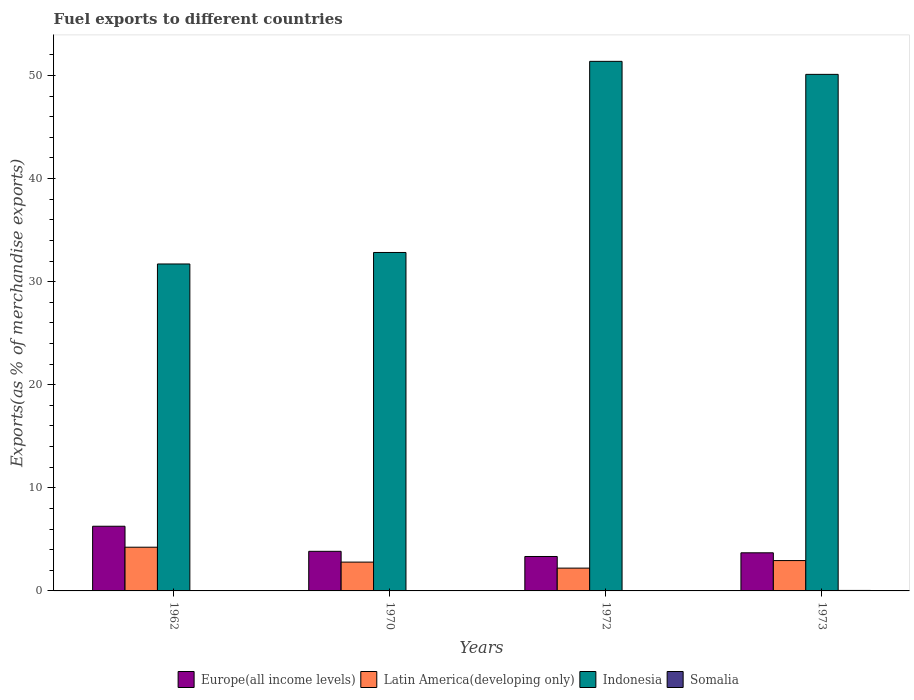How many groups of bars are there?
Your answer should be compact. 4. Are the number of bars per tick equal to the number of legend labels?
Your response must be concise. Yes. Are the number of bars on each tick of the X-axis equal?
Provide a succinct answer. Yes. How many bars are there on the 4th tick from the left?
Offer a terse response. 4. How many bars are there on the 1st tick from the right?
Make the answer very short. 4. What is the label of the 1st group of bars from the left?
Make the answer very short. 1962. In how many cases, is the number of bars for a given year not equal to the number of legend labels?
Offer a very short reply. 0. What is the percentage of exports to different countries in Indonesia in 1972?
Ensure brevity in your answer.  51.36. Across all years, what is the maximum percentage of exports to different countries in Somalia?
Ensure brevity in your answer.  0.05. Across all years, what is the minimum percentage of exports to different countries in Latin America(developing only)?
Your response must be concise. 2.21. What is the total percentage of exports to different countries in Latin America(developing only) in the graph?
Offer a very short reply. 12.19. What is the difference between the percentage of exports to different countries in Europe(all income levels) in 1962 and that in 1973?
Provide a short and direct response. 2.58. What is the difference between the percentage of exports to different countries in Indonesia in 1962 and the percentage of exports to different countries in Latin America(developing only) in 1970?
Offer a very short reply. 28.92. What is the average percentage of exports to different countries in Latin America(developing only) per year?
Ensure brevity in your answer.  3.05. In the year 1972, what is the difference between the percentage of exports to different countries in Indonesia and percentage of exports to different countries in Latin America(developing only)?
Your response must be concise. 49.15. In how many years, is the percentage of exports to different countries in Indonesia greater than 38 %?
Offer a terse response. 2. What is the ratio of the percentage of exports to different countries in Somalia in 1962 to that in 1972?
Your response must be concise. 0.26. Is the difference between the percentage of exports to different countries in Indonesia in 1962 and 1972 greater than the difference between the percentage of exports to different countries in Latin America(developing only) in 1962 and 1972?
Your answer should be very brief. No. What is the difference between the highest and the second highest percentage of exports to different countries in Indonesia?
Ensure brevity in your answer.  1.26. What is the difference between the highest and the lowest percentage of exports to different countries in Latin America(developing only)?
Offer a terse response. 2.03. In how many years, is the percentage of exports to different countries in Somalia greater than the average percentage of exports to different countries in Somalia taken over all years?
Make the answer very short. 1. Is the sum of the percentage of exports to different countries in Indonesia in 1962 and 1973 greater than the maximum percentage of exports to different countries in Latin America(developing only) across all years?
Provide a short and direct response. Yes. Is it the case that in every year, the sum of the percentage of exports to different countries in Somalia and percentage of exports to different countries in Latin America(developing only) is greater than the sum of percentage of exports to different countries in Indonesia and percentage of exports to different countries in Europe(all income levels)?
Provide a short and direct response. No. What does the 2nd bar from the left in 1972 represents?
Your response must be concise. Latin America(developing only). Are all the bars in the graph horizontal?
Your answer should be compact. No. Are the values on the major ticks of Y-axis written in scientific E-notation?
Offer a very short reply. No. Does the graph contain any zero values?
Give a very brief answer. No. Where does the legend appear in the graph?
Your response must be concise. Bottom center. How many legend labels are there?
Offer a very short reply. 4. How are the legend labels stacked?
Make the answer very short. Horizontal. What is the title of the graph?
Ensure brevity in your answer.  Fuel exports to different countries. What is the label or title of the Y-axis?
Give a very brief answer. Exports(as % of merchandise exports). What is the Exports(as % of merchandise exports) of Europe(all income levels) in 1962?
Offer a very short reply. 6.27. What is the Exports(as % of merchandise exports) of Latin America(developing only) in 1962?
Make the answer very short. 4.24. What is the Exports(as % of merchandise exports) of Indonesia in 1962?
Ensure brevity in your answer.  31.71. What is the Exports(as % of merchandise exports) of Somalia in 1962?
Provide a short and direct response. 0. What is the Exports(as % of merchandise exports) of Europe(all income levels) in 1970?
Keep it short and to the point. 3.84. What is the Exports(as % of merchandise exports) in Latin America(developing only) in 1970?
Your response must be concise. 2.8. What is the Exports(as % of merchandise exports) in Indonesia in 1970?
Give a very brief answer. 32.83. What is the Exports(as % of merchandise exports) of Somalia in 1970?
Your answer should be compact. 0. What is the Exports(as % of merchandise exports) in Europe(all income levels) in 1972?
Your answer should be compact. 3.34. What is the Exports(as % of merchandise exports) of Latin America(developing only) in 1972?
Make the answer very short. 2.21. What is the Exports(as % of merchandise exports) in Indonesia in 1972?
Provide a short and direct response. 51.36. What is the Exports(as % of merchandise exports) of Somalia in 1972?
Offer a terse response. 0.01. What is the Exports(as % of merchandise exports) of Europe(all income levels) in 1973?
Provide a short and direct response. 3.7. What is the Exports(as % of merchandise exports) of Latin America(developing only) in 1973?
Your answer should be compact. 2.94. What is the Exports(as % of merchandise exports) in Indonesia in 1973?
Your answer should be very brief. 50.1. What is the Exports(as % of merchandise exports) in Somalia in 1973?
Your answer should be compact. 0.05. Across all years, what is the maximum Exports(as % of merchandise exports) of Europe(all income levels)?
Make the answer very short. 6.27. Across all years, what is the maximum Exports(as % of merchandise exports) in Latin America(developing only)?
Keep it short and to the point. 4.24. Across all years, what is the maximum Exports(as % of merchandise exports) in Indonesia?
Ensure brevity in your answer.  51.36. Across all years, what is the maximum Exports(as % of merchandise exports) of Somalia?
Give a very brief answer. 0.05. Across all years, what is the minimum Exports(as % of merchandise exports) of Europe(all income levels)?
Give a very brief answer. 3.34. Across all years, what is the minimum Exports(as % of merchandise exports) in Latin America(developing only)?
Keep it short and to the point. 2.21. Across all years, what is the minimum Exports(as % of merchandise exports) of Indonesia?
Your answer should be compact. 31.71. Across all years, what is the minimum Exports(as % of merchandise exports) in Somalia?
Ensure brevity in your answer.  0. What is the total Exports(as % of merchandise exports) in Europe(all income levels) in the graph?
Provide a short and direct response. 17.15. What is the total Exports(as % of merchandise exports) in Latin America(developing only) in the graph?
Your response must be concise. 12.19. What is the total Exports(as % of merchandise exports) of Indonesia in the graph?
Keep it short and to the point. 166. What is the total Exports(as % of merchandise exports) of Somalia in the graph?
Ensure brevity in your answer.  0.06. What is the difference between the Exports(as % of merchandise exports) of Europe(all income levels) in 1962 and that in 1970?
Ensure brevity in your answer.  2.43. What is the difference between the Exports(as % of merchandise exports) of Latin America(developing only) in 1962 and that in 1970?
Offer a terse response. 1.44. What is the difference between the Exports(as % of merchandise exports) in Indonesia in 1962 and that in 1970?
Keep it short and to the point. -1.11. What is the difference between the Exports(as % of merchandise exports) in Somalia in 1962 and that in 1970?
Your response must be concise. 0. What is the difference between the Exports(as % of merchandise exports) of Europe(all income levels) in 1962 and that in 1972?
Make the answer very short. 2.93. What is the difference between the Exports(as % of merchandise exports) of Latin America(developing only) in 1962 and that in 1972?
Give a very brief answer. 2.03. What is the difference between the Exports(as % of merchandise exports) in Indonesia in 1962 and that in 1972?
Offer a very short reply. -19.65. What is the difference between the Exports(as % of merchandise exports) of Somalia in 1962 and that in 1972?
Keep it short and to the point. -0.01. What is the difference between the Exports(as % of merchandise exports) of Europe(all income levels) in 1962 and that in 1973?
Provide a short and direct response. 2.58. What is the difference between the Exports(as % of merchandise exports) of Latin America(developing only) in 1962 and that in 1973?
Your answer should be compact. 1.3. What is the difference between the Exports(as % of merchandise exports) in Indonesia in 1962 and that in 1973?
Offer a terse response. -18.39. What is the difference between the Exports(as % of merchandise exports) of Somalia in 1962 and that in 1973?
Provide a short and direct response. -0.04. What is the difference between the Exports(as % of merchandise exports) in Europe(all income levels) in 1970 and that in 1972?
Provide a short and direct response. 0.5. What is the difference between the Exports(as % of merchandise exports) in Latin America(developing only) in 1970 and that in 1972?
Your answer should be compact. 0.58. What is the difference between the Exports(as % of merchandise exports) in Indonesia in 1970 and that in 1972?
Give a very brief answer. -18.54. What is the difference between the Exports(as % of merchandise exports) in Somalia in 1970 and that in 1972?
Ensure brevity in your answer.  -0.01. What is the difference between the Exports(as % of merchandise exports) of Europe(all income levels) in 1970 and that in 1973?
Give a very brief answer. 0.14. What is the difference between the Exports(as % of merchandise exports) of Latin America(developing only) in 1970 and that in 1973?
Offer a very short reply. -0.15. What is the difference between the Exports(as % of merchandise exports) of Indonesia in 1970 and that in 1973?
Your answer should be very brief. -17.28. What is the difference between the Exports(as % of merchandise exports) in Somalia in 1970 and that in 1973?
Give a very brief answer. -0.05. What is the difference between the Exports(as % of merchandise exports) in Europe(all income levels) in 1972 and that in 1973?
Your response must be concise. -0.36. What is the difference between the Exports(as % of merchandise exports) in Latin America(developing only) in 1972 and that in 1973?
Keep it short and to the point. -0.73. What is the difference between the Exports(as % of merchandise exports) of Indonesia in 1972 and that in 1973?
Offer a very short reply. 1.26. What is the difference between the Exports(as % of merchandise exports) in Somalia in 1972 and that in 1973?
Your answer should be very brief. -0.04. What is the difference between the Exports(as % of merchandise exports) in Europe(all income levels) in 1962 and the Exports(as % of merchandise exports) in Latin America(developing only) in 1970?
Offer a terse response. 3.48. What is the difference between the Exports(as % of merchandise exports) of Europe(all income levels) in 1962 and the Exports(as % of merchandise exports) of Indonesia in 1970?
Offer a very short reply. -26.55. What is the difference between the Exports(as % of merchandise exports) of Europe(all income levels) in 1962 and the Exports(as % of merchandise exports) of Somalia in 1970?
Give a very brief answer. 6.27. What is the difference between the Exports(as % of merchandise exports) of Latin America(developing only) in 1962 and the Exports(as % of merchandise exports) of Indonesia in 1970?
Provide a short and direct response. -28.59. What is the difference between the Exports(as % of merchandise exports) in Latin America(developing only) in 1962 and the Exports(as % of merchandise exports) in Somalia in 1970?
Offer a terse response. 4.24. What is the difference between the Exports(as % of merchandise exports) in Indonesia in 1962 and the Exports(as % of merchandise exports) in Somalia in 1970?
Offer a very short reply. 31.71. What is the difference between the Exports(as % of merchandise exports) in Europe(all income levels) in 1962 and the Exports(as % of merchandise exports) in Latin America(developing only) in 1972?
Keep it short and to the point. 4.06. What is the difference between the Exports(as % of merchandise exports) in Europe(all income levels) in 1962 and the Exports(as % of merchandise exports) in Indonesia in 1972?
Your response must be concise. -45.09. What is the difference between the Exports(as % of merchandise exports) in Europe(all income levels) in 1962 and the Exports(as % of merchandise exports) in Somalia in 1972?
Provide a short and direct response. 6.26. What is the difference between the Exports(as % of merchandise exports) of Latin America(developing only) in 1962 and the Exports(as % of merchandise exports) of Indonesia in 1972?
Keep it short and to the point. -47.13. What is the difference between the Exports(as % of merchandise exports) in Latin America(developing only) in 1962 and the Exports(as % of merchandise exports) in Somalia in 1972?
Provide a short and direct response. 4.23. What is the difference between the Exports(as % of merchandise exports) in Indonesia in 1962 and the Exports(as % of merchandise exports) in Somalia in 1972?
Make the answer very short. 31.7. What is the difference between the Exports(as % of merchandise exports) of Europe(all income levels) in 1962 and the Exports(as % of merchandise exports) of Latin America(developing only) in 1973?
Provide a succinct answer. 3.33. What is the difference between the Exports(as % of merchandise exports) of Europe(all income levels) in 1962 and the Exports(as % of merchandise exports) of Indonesia in 1973?
Keep it short and to the point. -43.83. What is the difference between the Exports(as % of merchandise exports) of Europe(all income levels) in 1962 and the Exports(as % of merchandise exports) of Somalia in 1973?
Make the answer very short. 6.23. What is the difference between the Exports(as % of merchandise exports) of Latin America(developing only) in 1962 and the Exports(as % of merchandise exports) of Indonesia in 1973?
Provide a succinct answer. -45.86. What is the difference between the Exports(as % of merchandise exports) of Latin America(developing only) in 1962 and the Exports(as % of merchandise exports) of Somalia in 1973?
Your answer should be compact. 4.19. What is the difference between the Exports(as % of merchandise exports) of Indonesia in 1962 and the Exports(as % of merchandise exports) of Somalia in 1973?
Your answer should be very brief. 31.66. What is the difference between the Exports(as % of merchandise exports) in Europe(all income levels) in 1970 and the Exports(as % of merchandise exports) in Latin America(developing only) in 1972?
Give a very brief answer. 1.63. What is the difference between the Exports(as % of merchandise exports) in Europe(all income levels) in 1970 and the Exports(as % of merchandise exports) in Indonesia in 1972?
Offer a terse response. -47.52. What is the difference between the Exports(as % of merchandise exports) of Europe(all income levels) in 1970 and the Exports(as % of merchandise exports) of Somalia in 1972?
Your answer should be very brief. 3.83. What is the difference between the Exports(as % of merchandise exports) in Latin America(developing only) in 1970 and the Exports(as % of merchandise exports) in Indonesia in 1972?
Offer a terse response. -48.57. What is the difference between the Exports(as % of merchandise exports) of Latin America(developing only) in 1970 and the Exports(as % of merchandise exports) of Somalia in 1972?
Offer a very short reply. 2.78. What is the difference between the Exports(as % of merchandise exports) of Indonesia in 1970 and the Exports(as % of merchandise exports) of Somalia in 1972?
Your answer should be very brief. 32.81. What is the difference between the Exports(as % of merchandise exports) of Europe(all income levels) in 1970 and the Exports(as % of merchandise exports) of Latin America(developing only) in 1973?
Your response must be concise. 0.9. What is the difference between the Exports(as % of merchandise exports) of Europe(all income levels) in 1970 and the Exports(as % of merchandise exports) of Indonesia in 1973?
Provide a short and direct response. -46.26. What is the difference between the Exports(as % of merchandise exports) of Europe(all income levels) in 1970 and the Exports(as % of merchandise exports) of Somalia in 1973?
Make the answer very short. 3.79. What is the difference between the Exports(as % of merchandise exports) in Latin America(developing only) in 1970 and the Exports(as % of merchandise exports) in Indonesia in 1973?
Your answer should be very brief. -47.31. What is the difference between the Exports(as % of merchandise exports) in Latin America(developing only) in 1970 and the Exports(as % of merchandise exports) in Somalia in 1973?
Ensure brevity in your answer.  2.75. What is the difference between the Exports(as % of merchandise exports) of Indonesia in 1970 and the Exports(as % of merchandise exports) of Somalia in 1973?
Make the answer very short. 32.78. What is the difference between the Exports(as % of merchandise exports) in Europe(all income levels) in 1972 and the Exports(as % of merchandise exports) in Latin America(developing only) in 1973?
Offer a very short reply. 0.4. What is the difference between the Exports(as % of merchandise exports) in Europe(all income levels) in 1972 and the Exports(as % of merchandise exports) in Indonesia in 1973?
Ensure brevity in your answer.  -46.76. What is the difference between the Exports(as % of merchandise exports) of Europe(all income levels) in 1972 and the Exports(as % of merchandise exports) of Somalia in 1973?
Ensure brevity in your answer.  3.29. What is the difference between the Exports(as % of merchandise exports) in Latin America(developing only) in 1972 and the Exports(as % of merchandise exports) in Indonesia in 1973?
Give a very brief answer. -47.89. What is the difference between the Exports(as % of merchandise exports) of Latin America(developing only) in 1972 and the Exports(as % of merchandise exports) of Somalia in 1973?
Your answer should be compact. 2.17. What is the difference between the Exports(as % of merchandise exports) of Indonesia in 1972 and the Exports(as % of merchandise exports) of Somalia in 1973?
Keep it short and to the point. 51.32. What is the average Exports(as % of merchandise exports) in Europe(all income levels) per year?
Your answer should be compact. 4.29. What is the average Exports(as % of merchandise exports) of Latin America(developing only) per year?
Your response must be concise. 3.05. What is the average Exports(as % of merchandise exports) of Indonesia per year?
Ensure brevity in your answer.  41.5. What is the average Exports(as % of merchandise exports) in Somalia per year?
Keep it short and to the point. 0.02. In the year 1962, what is the difference between the Exports(as % of merchandise exports) in Europe(all income levels) and Exports(as % of merchandise exports) in Latin America(developing only)?
Keep it short and to the point. 2.03. In the year 1962, what is the difference between the Exports(as % of merchandise exports) in Europe(all income levels) and Exports(as % of merchandise exports) in Indonesia?
Make the answer very short. -25.44. In the year 1962, what is the difference between the Exports(as % of merchandise exports) in Europe(all income levels) and Exports(as % of merchandise exports) in Somalia?
Provide a short and direct response. 6.27. In the year 1962, what is the difference between the Exports(as % of merchandise exports) of Latin America(developing only) and Exports(as % of merchandise exports) of Indonesia?
Provide a succinct answer. -27.47. In the year 1962, what is the difference between the Exports(as % of merchandise exports) in Latin America(developing only) and Exports(as % of merchandise exports) in Somalia?
Offer a terse response. 4.24. In the year 1962, what is the difference between the Exports(as % of merchandise exports) in Indonesia and Exports(as % of merchandise exports) in Somalia?
Offer a terse response. 31.71. In the year 1970, what is the difference between the Exports(as % of merchandise exports) in Europe(all income levels) and Exports(as % of merchandise exports) in Latin America(developing only)?
Keep it short and to the point. 1.05. In the year 1970, what is the difference between the Exports(as % of merchandise exports) in Europe(all income levels) and Exports(as % of merchandise exports) in Indonesia?
Provide a short and direct response. -28.99. In the year 1970, what is the difference between the Exports(as % of merchandise exports) in Europe(all income levels) and Exports(as % of merchandise exports) in Somalia?
Offer a terse response. 3.84. In the year 1970, what is the difference between the Exports(as % of merchandise exports) of Latin America(developing only) and Exports(as % of merchandise exports) of Indonesia?
Your response must be concise. -30.03. In the year 1970, what is the difference between the Exports(as % of merchandise exports) of Latin America(developing only) and Exports(as % of merchandise exports) of Somalia?
Ensure brevity in your answer.  2.8. In the year 1970, what is the difference between the Exports(as % of merchandise exports) of Indonesia and Exports(as % of merchandise exports) of Somalia?
Give a very brief answer. 32.83. In the year 1972, what is the difference between the Exports(as % of merchandise exports) in Europe(all income levels) and Exports(as % of merchandise exports) in Latin America(developing only)?
Offer a very short reply. 1.13. In the year 1972, what is the difference between the Exports(as % of merchandise exports) in Europe(all income levels) and Exports(as % of merchandise exports) in Indonesia?
Ensure brevity in your answer.  -48.03. In the year 1972, what is the difference between the Exports(as % of merchandise exports) of Europe(all income levels) and Exports(as % of merchandise exports) of Somalia?
Keep it short and to the point. 3.33. In the year 1972, what is the difference between the Exports(as % of merchandise exports) in Latin America(developing only) and Exports(as % of merchandise exports) in Indonesia?
Ensure brevity in your answer.  -49.15. In the year 1972, what is the difference between the Exports(as % of merchandise exports) of Latin America(developing only) and Exports(as % of merchandise exports) of Somalia?
Your response must be concise. 2.2. In the year 1972, what is the difference between the Exports(as % of merchandise exports) of Indonesia and Exports(as % of merchandise exports) of Somalia?
Provide a short and direct response. 51.35. In the year 1973, what is the difference between the Exports(as % of merchandise exports) of Europe(all income levels) and Exports(as % of merchandise exports) of Latin America(developing only)?
Ensure brevity in your answer.  0.75. In the year 1973, what is the difference between the Exports(as % of merchandise exports) in Europe(all income levels) and Exports(as % of merchandise exports) in Indonesia?
Ensure brevity in your answer.  -46.4. In the year 1973, what is the difference between the Exports(as % of merchandise exports) in Europe(all income levels) and Exports(as % of merchandise exports) in Somalia?
Offer a very short reply. 3.65. In the year 1973, what is the difference between the Exports(as % of merchandise exports) in Latin America(developing only) and Exports(as % of merchandise exports) in Indonesia?
Your answer should be compact. -47.16. In the year 1973, what is the difference between the Exports(as % of merchandise exports) of Latin America(developing only) and Exports(as % of merchandise exports) of Somalia?
Provide a short and direct response. 2.9. In the year 1973, what is the difference between the Exports(as % of merchandise exports) of Indonesia and Exports(as % of merchandise exports) of Somalia?
Provide a succinct answer. 50.05. What is the ratio of the Exports(as % of merchandise exports) in Europe(all income levels) in 1962 to that in 1970?
Provide a succinct answer. 1.63. What is the ratio of the Exports(as % of merchandise exports) in Latin America(developing only) in 1962 to that in 1970?
Offer a terse response. 1.52. What is the ratio of the Exports(as % of merchandise exports) of Indonesia in 1962 to that in 1970?
Offer a terse response. 0.97. What is the ratio of the Exports(as % of merchandise exports) in Somalia in 1962 to that in 1970?
Make the answer very short. 15.2. What is the ratio of the Exports(as % of merchandise exports) of Europe(all income levels) in 1962 to that in 1972?
Make the answer very short. 1.88. What is the ratio of the Exports(as % of merchandise exports) of Latin America(developing only) in 1962 to that in 1972?
Keep it short and to the point. 1.92. What is the ratio of the Exports(as % of merchandise exports) in Indonesia in 1962 to that in 1972?
Keep it short and to the point. 0.62. What is the ratio of the Exports(as % of merchandise exports) of Somalia in 1962 to that in 1972?
Offer a terse response. 0.26. What is the ratio of the Exports(as % of merchandise exports) of Europe(all income levels) in 1962 to that in 1973?
Provide a short and direct response. 1.7. What is the ratio of the Exports(as % of merchandise exports) of Latin America(developing only) in 1962 to that in 1973?
Keep it short and to the point. 1.44. What is the ratio of the Exports(as % of merchandise exports) of Indonesia in 1962 to that in 1973?
Offer a terse response. 0.63. What is the ratio of the Exports(as % of merchandise exports) of Somalia in 1962 to that in 1973?
Give a very brief answer. 0.06. What is the ratio of the Exports(as % of merchandise exports) of Europe(all income levels) in 1970 to that in 1972?
Keep it short and to the point. 1.15. What is the ratio of the Exports(as % of merchandise exports) of Latin America(developing only) in 1970 to that in 1972?
Keep it short and to the point. 1.26. What is the ratio of the Exports(as % of merchandise exports) of Indonesia in 1970 to that in 1972?
Provide a short and direct response. 0.64. What is the ratio of the Exports(as % of merchandise exports) in Somalia in 1970 to that in 1972?
Offer a terse response. 0.02. What is the ratio of the Exports(as % of merchandise exports) in Europe(all income levels) in 1970 to that in 1973?
Your response must be concise. 1.04. What is the ratio of the Exports(as % of merchandise exports) of Latin America(developing only) in 1970 to that in 1973?
Provide a succinct answer. 0.95. What is the ratio of the Exports(as % of merchandise exports) in Indonesia in 1970 to that in 1973?
Offer a very short reply. 0.66. What is the ratio of the Exports(as % of merchandise exports) in Somalia in 1970 to that in 1973?
Give a very brief answer. 0. What is the ratio of the Exports(as % of merchandise exports) of Europe(all income levels) in 1972 to that in 1973?
Keep it short and to the point. 0.9. What is the ratio of the Exports(as % of merchandise exports) in Latin America(developing only) in 1972 to that in 1973?
Your answer should be compact. 0.75. What is the ratio of the Exports(as % of merchandise exports) of Indonesia in 1972 to that in 1973?
Make the answer very short. 1.03. What is the ratio of the Exports(as % of merchandise exports) in Somalia in 1972 to that in 1973?
Your response must be concise. 0.24. What is the difference between the highest and the second highest Exports(as % of merchandise exports) of Europe(all income levels)?
Make the answer very short. 2.43. What is the difference between the highest and the second highest Exports(as % of merchandise exports) in Latin America(developing only)?
Ensure brevity in your answer.  1.3. What is the difference between the highest and the second highest Exports(as % of merchandise exports) of Indonesia?
Give a very brief answer. 1.26. What is the difference between the highest and the second highest Exports(as % of merchandise exports) of Somalia?
Provide a succinct answer. 0.04. What is the difference between the highest and the lowest Exports(as % of merchandise exports) in Europe(all income levels)?
Provide a short and direct response. 2.93. What is the difference between the highest and the lowest Exports(as % of merchandise exports) of Latin America(developing only)?
Make the answer very short. 2.03. What is the difference between the highest and the lowest Exports(as % of merchandise exports) of Indonesia?
Provide a short and direct response. 19.65. What is the difference between the highest and the lowest Exports(as % of merchandise exports) in Somalia?
Keep it short and to the point. 0.05. 